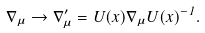<formula> <loc_0><loc_0><loc_500><loc_500>\nabla _ { \mu } \rightarrow \nabla _ { \mu } ^ { \prime } = { U } ( x ) \nabla _ { \mu } { U } ( x ) ^ { - 1 } .</formula> 